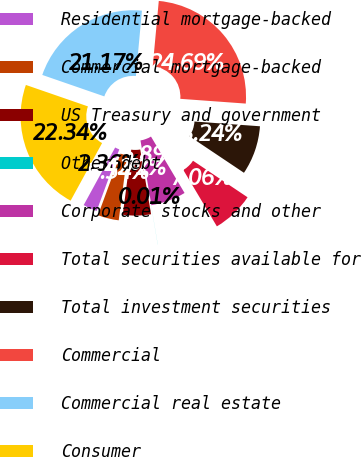<chart> <loc_0><loc_0><loc_500><loc_500><pie_chart><fcel>Residential mortgage-backed<fcel>Commercial mortgage-backed<fcel>US Treasury and government<fcel>Other debt<fcel>Corporate stocks and other<fcel>Total securities available for<fcel>Total investment securities<fcel>Commercial<fcel>Commercial real estate<fcel>Consumer<nl><fcel>2.36%<fcel>3.54%<fcel>4.71%<fcel>0.01%<fcel>5.89%<fcel>7.06%<fcel>8.24%<fcel>24.69%<fcel>21.17%<fcel>22.34%<nl></chart> 